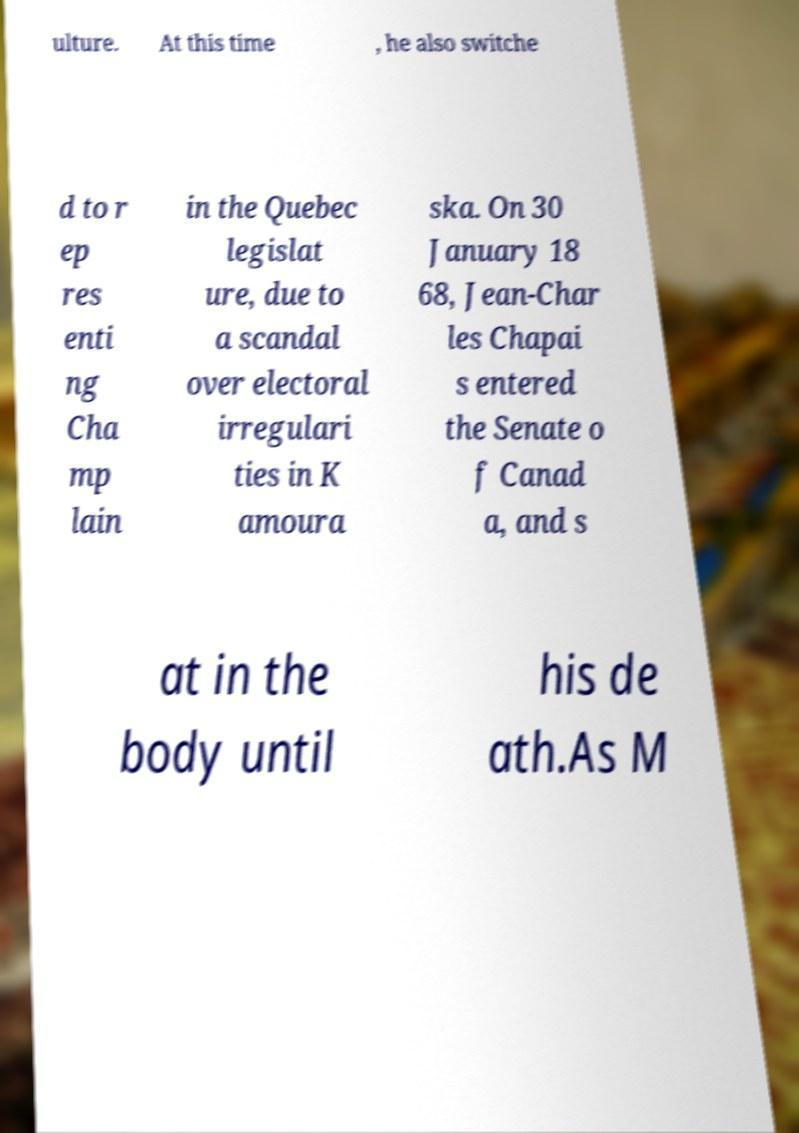I need the written content from this picture converted into text. Can you do that? ulture. At this time , he also switche d to r ep res enti ng Cha mp lain in the Quebec legislat ure, due to a scandal over electoral irregulari ties in K amoura ska. On 30 January 18 68, Jean-Char les Chapai s entered the Senate o f Canad a, and s at in the body until his de ath.As M 